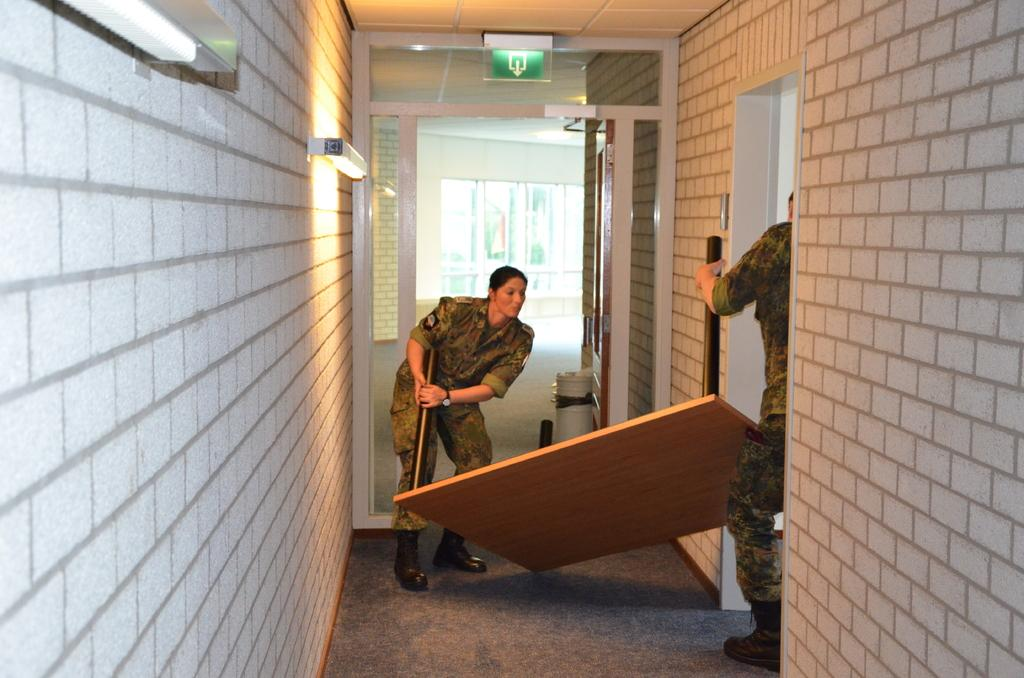Who is the main subject in the image? There is a woman in the image. Can you describe the other person in the image? There is another person in the image, on the right side. What is separating the two people in the image? There is a piece of wood between the two people. What can be seen in the background of the image? There are lights and walls visible in the image. What direction is the woman facing in the image? The direction the woman is facing cannot be determined from the image alone. What is the thumb doing in the image? There is no thumb present in the image. 